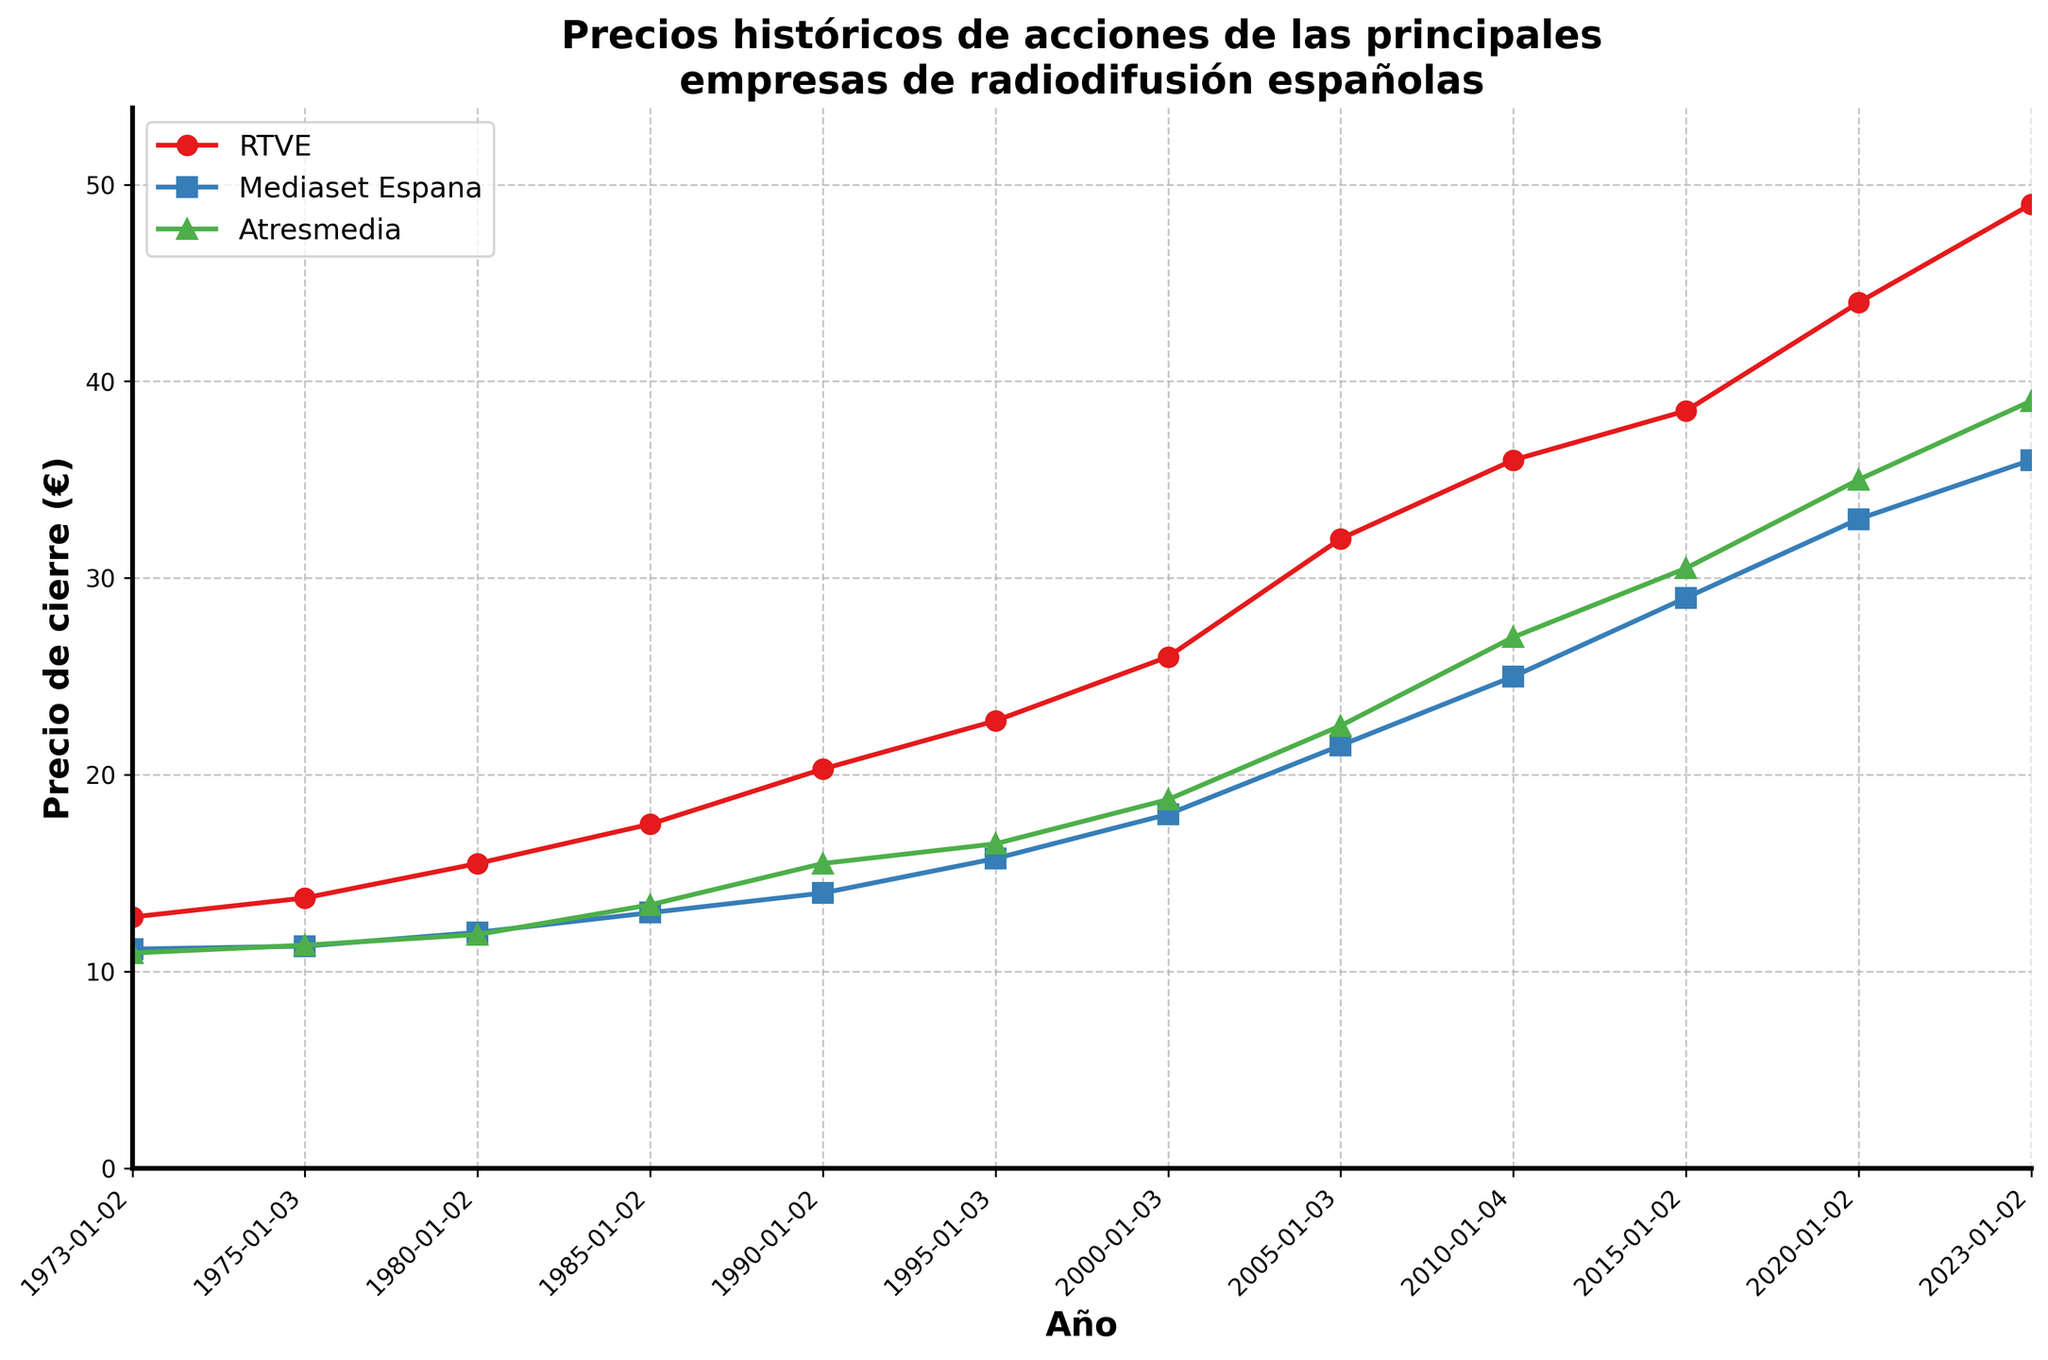What is the title of the plot? The title is usually positioned at the top of the plot and describes the type of data being visualized. The title here is in Spanish.
Answer: Precios históricos de acciones de las principales empresas de radiodifusión españolas What is the label for the x-axis? The x-axis label explains what the data points along the horizontal axis represent. It's in Spanish.
Answer: Año Which company had the highest closing stock price in 2023? To find this, look at the data for the year 2023 and compare the closing stock prices of RTVE, Mediaset España, and Atresmedia.
Answer: RTVE How many major companies are represented in the plot? The plot shows different colors and markers for each company. By identifying the different lines, we see there are three companies represented.
Answer: 3 What is the trend in RTVE's stock price over the 50 years? To determine this, look at the path of RTVE's stock price from the earliest to the latest date on the x-axis. The price starts at 12.78 in 1973 and trends upwards, ending at 49.00 in 2023.
Answer: Increasing In which year did Mediaset España’s closing stock price first reach 21.50? To answer this, look for the point where Mediaset España’s stock price reaches 21.50 on the plot. This happened in 2005.
Answer: 2005 By how much did Atresmedia's closing stock price increase from 1990 to 2005? Calculate the difference between Atresmedia's closing stock price in 2005 (22.50) and in 1990 (15.50).
Answer: 7.00 In which year did Mediaset España have a higher closing stock price than Atresmedia for the first time? Compare the closing stock prices of both companies for each year until finding the first instance when Mediaset España's closing stock price is higher than Atresmedia's. This first occurs in 1990 when Mediaset España closes at 14.00 and Atresmedia at 15.50.
Answer: 2010 Which company had the smallest increase in closing stock price from 2010 to 2023? Calculate the increase for each company by subtracting the closing price in 2010 from the closing price in 2023. RTVE: 49.00 - 36.00 = 13.00, Mediaset España: 36.00 - 25.00 = 11.00, Atresmedia: 39.00 - 27.00 = 12.00. The smallest increase is for Mediaset España.
Answer: Mediaset España What is the average closing price of RTVE over the 50 years? Sum the closing prices of RTVE for all years and divide by the number of years (12). Calculation is: (12.78+13.75+15.50+17.50+20.30+22.75+26.00+32.00+36.00+38.50+44.00+49.00) / 12 = 28.18.
Answer: 28.18 